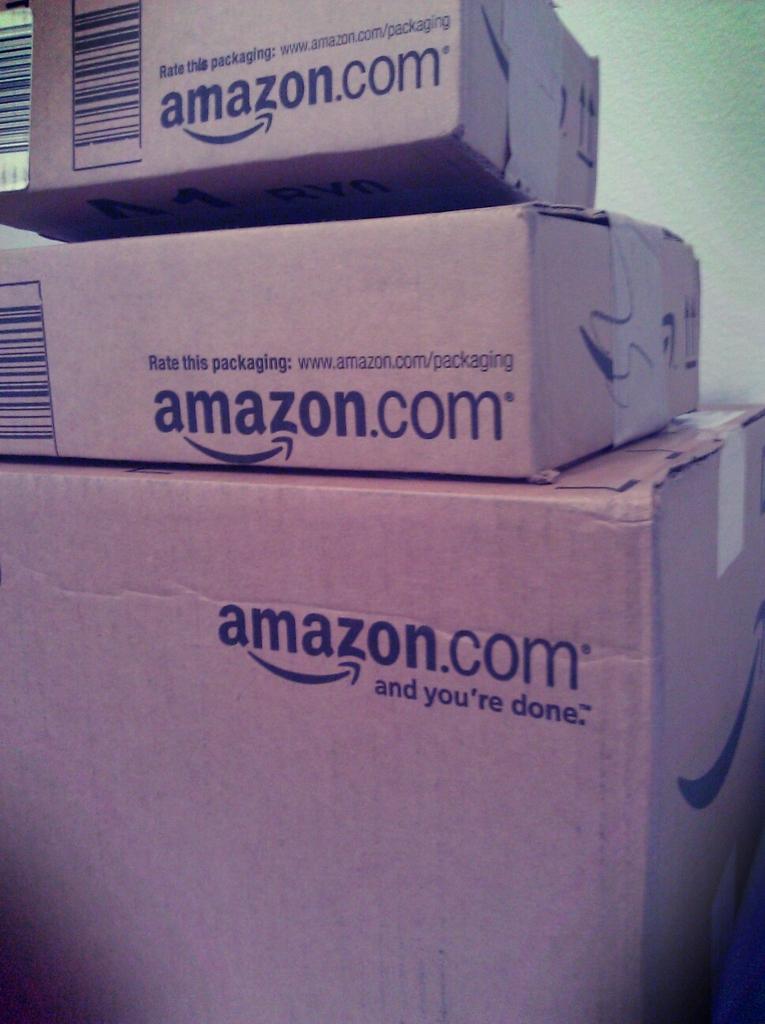Where are these packages from?
Your response must be concise. Amazon.com. 